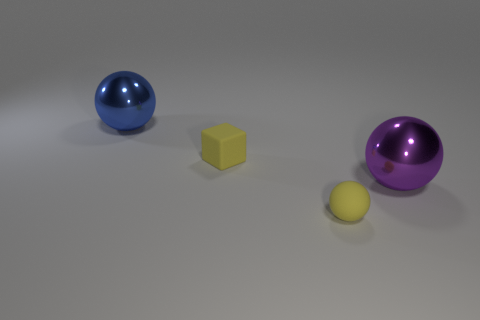What number of cyan things are either cubes or rubber things?
Offer a terse response. 0. There is a thing that is the same size as the matte block; what shape is it?
Offer a terse response. Sphere. How many other objects are there of the same color as the tiny matte sphere?
Your answer should be very brief. 1. There is a yellow ball that is to the right of the small yellow thing left of the matte ball; how big is it?
Provide a short and direct response. Small. Do the large thing that is in front of the small rubber cube and the large blue thing have the same material?
Give a very brief answer. Yes. There is a tiny thing on the right side of the yellow rubber cube; what is its shape?
Keep it short and to the point. Sphere. What number of purple metal balls have the same size as the blue metallic thing?
Ensure brevity in your answer.  1. The yellow sphere is what size?
Keep it short and to the point. Small. There is a matte block; how many shiny objects are right of it?
Give a very brief answer. 1. What shape is the big purple thing that is the same material as the blue sphere?
Make the answer very short. Sphere. 